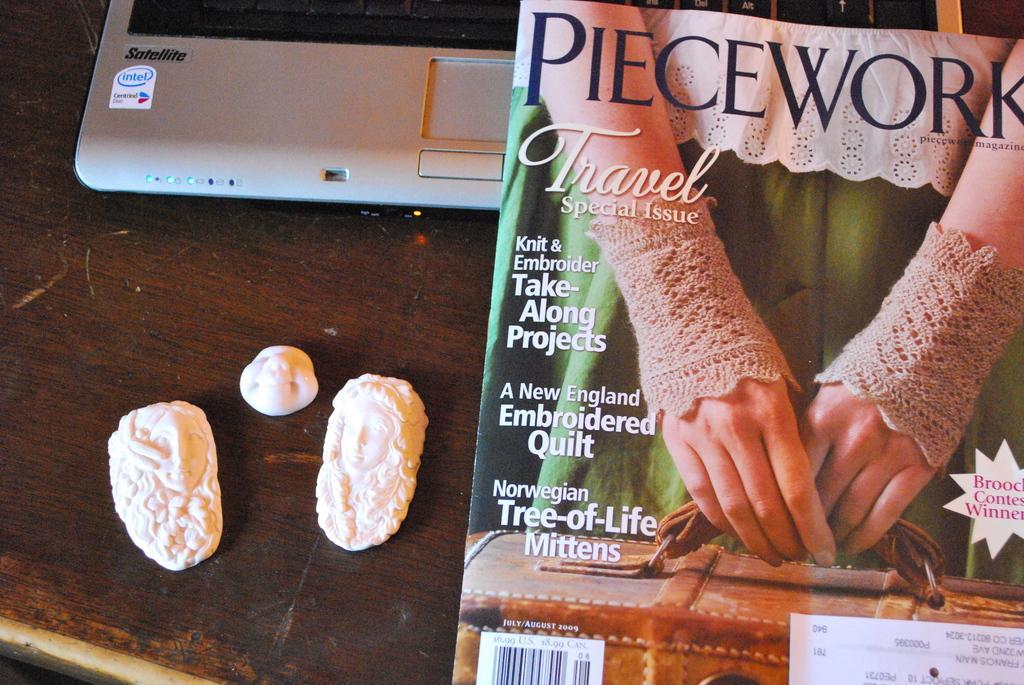Could you give a brief overview of what you see in this image? In this image there is a table. On top of it there is a laptop, magazine and a few other objects. 